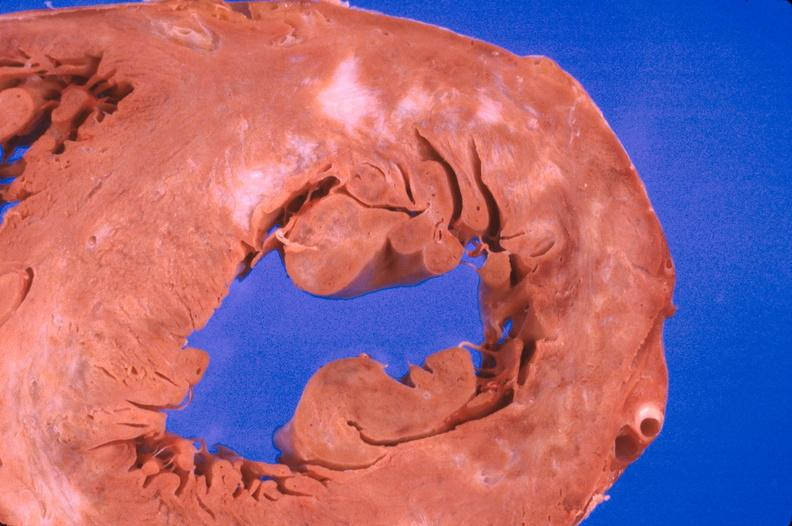s cardiovascular present?
Answer the question using a single word or phrase. Yes 